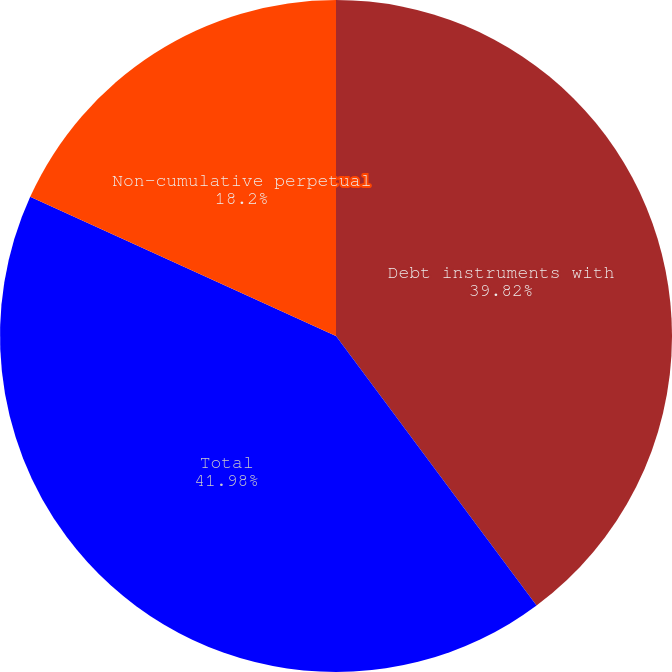Convert chart. <chart><loc_0><loc_0><loc_500><loc_500><pie_chart><fcel>Debt instruments with<fcel>Total<fcel>Non-cumulative perpetual<nl><fcel>39.82%<fcel>41.98%<fcel>18.2%<nl></chart> 